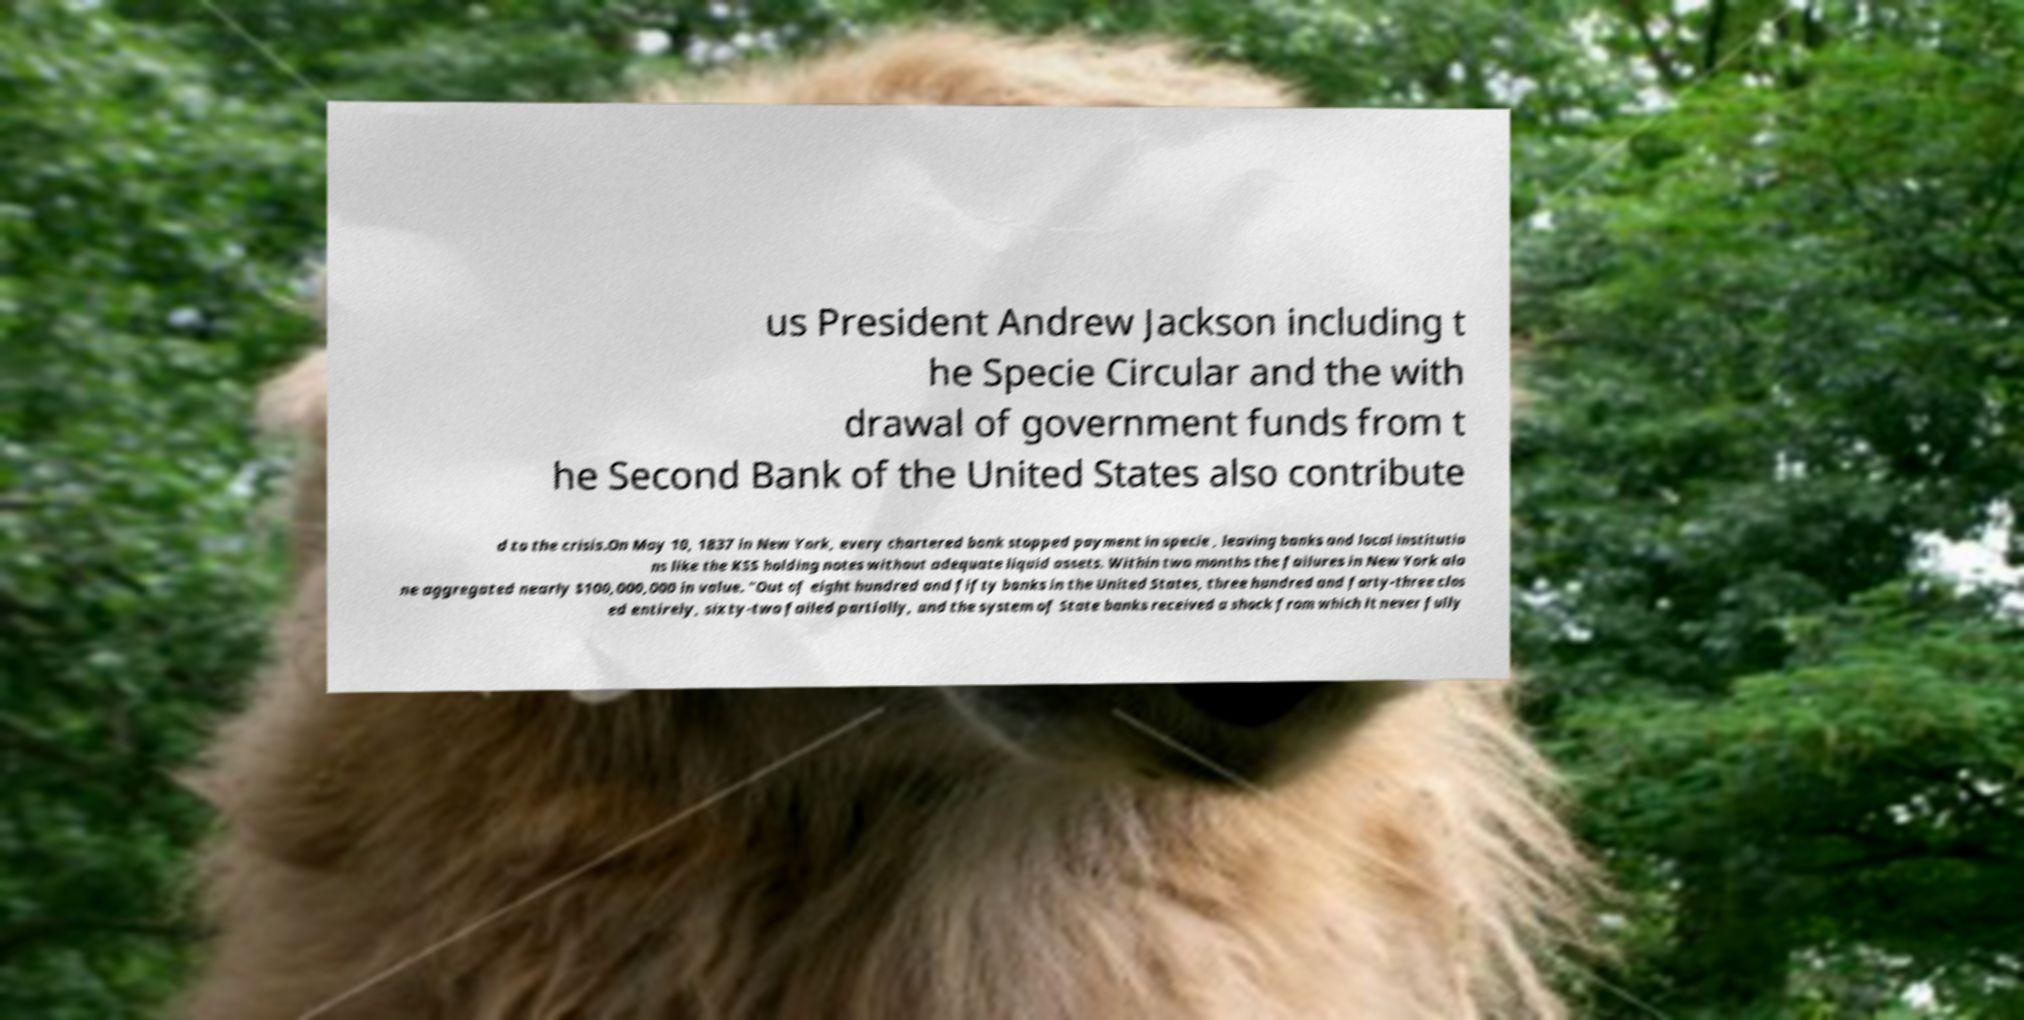Could you extract and type out the text from this image? us President Andrew Jackson including t he Specie Circular and the with drawal of government funds from t he Second Bank of the United States also contribute d to the crisis.On May 10, 1837 in New York, every chartered bank stopped payment in specie , leaving banks and local institutio ns like the KSS holding notes without adequate liquid assets. Within two months the failures in New York alo ne aggregated nearly $100,000,000 in value. "Out of eight hundred and fifty banks in the United States, three hundred and forty-three clos ed entirely, sixty-two failed partially, and the system of State banks received a shock from which it never fully 